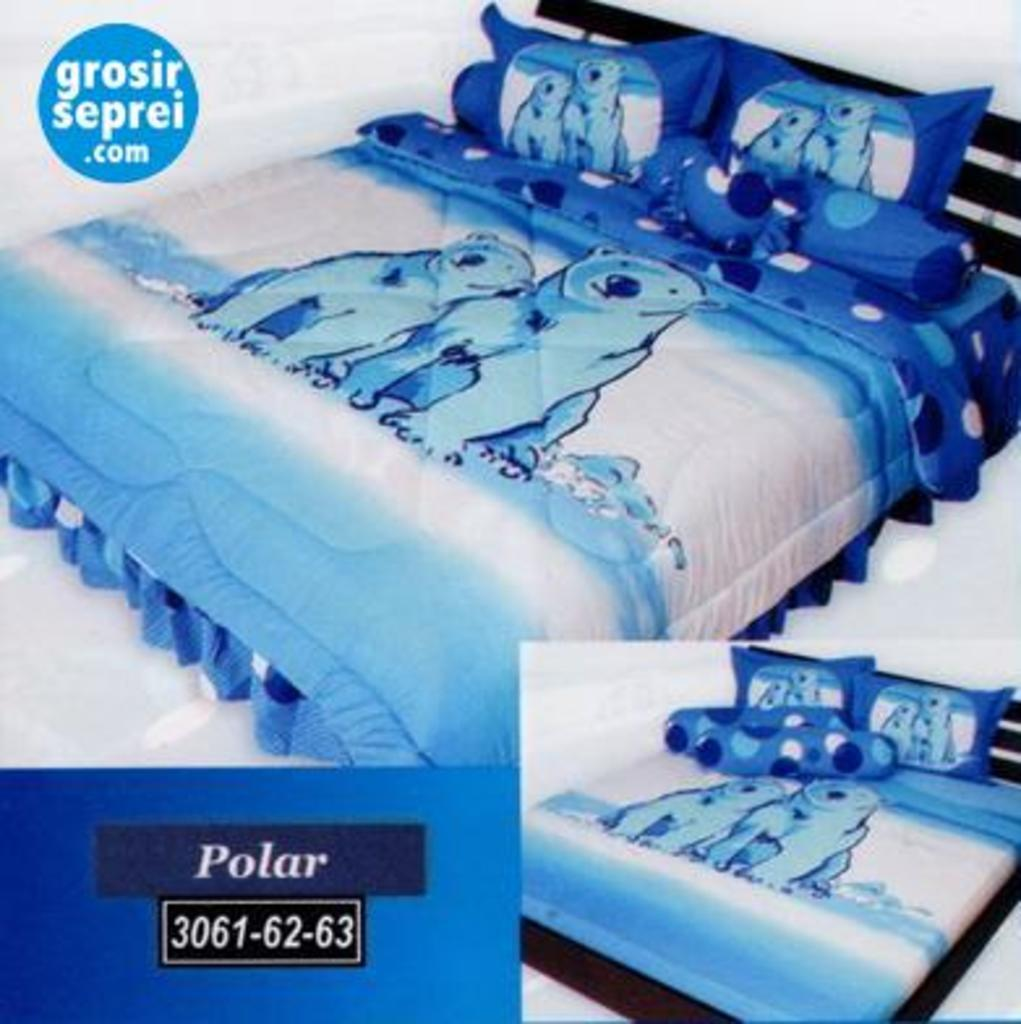What type of furniture is present in the image? There is a bed in the image. What accessories are on the bed? There are two pillows on the bed. What is covering the bed? There is a blanket on the bed. Where is the cactus located in the image? There is no cactus present in the image. What type of writing instrument is visible on the bed? There is no pen present in the image. 